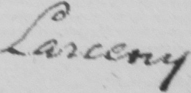What does this handwritten line say? Larceny 